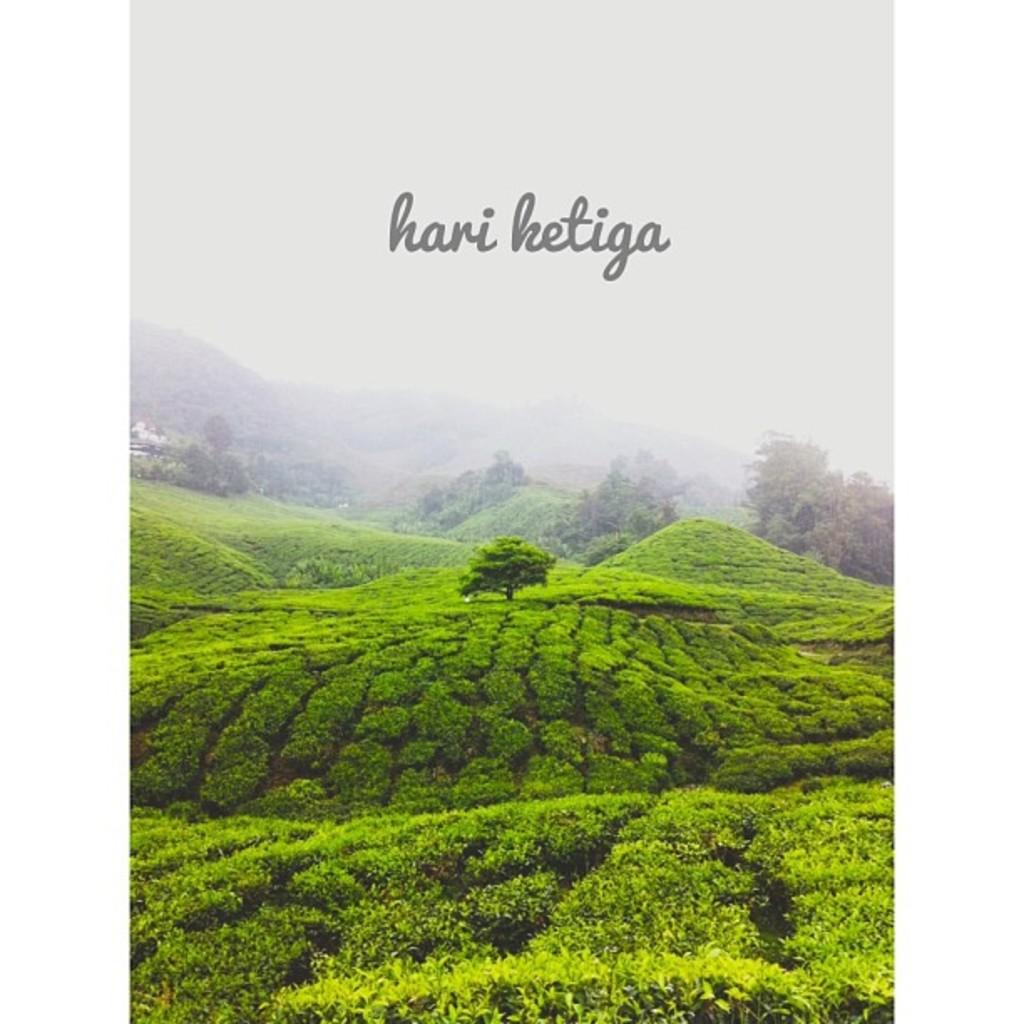What type of vegetation can be seen in the image? There are bushes and trees in the image. What natural feature is visible in the background of the image? There are mountains in the background of the image. What is written or displayed at the top of the image? There is text at the top of the image. Is there a fork being used to attack the bushes in the image? There is no fork or any form of attack present in the image. The image only features bushes, trees, mountains, and text. 